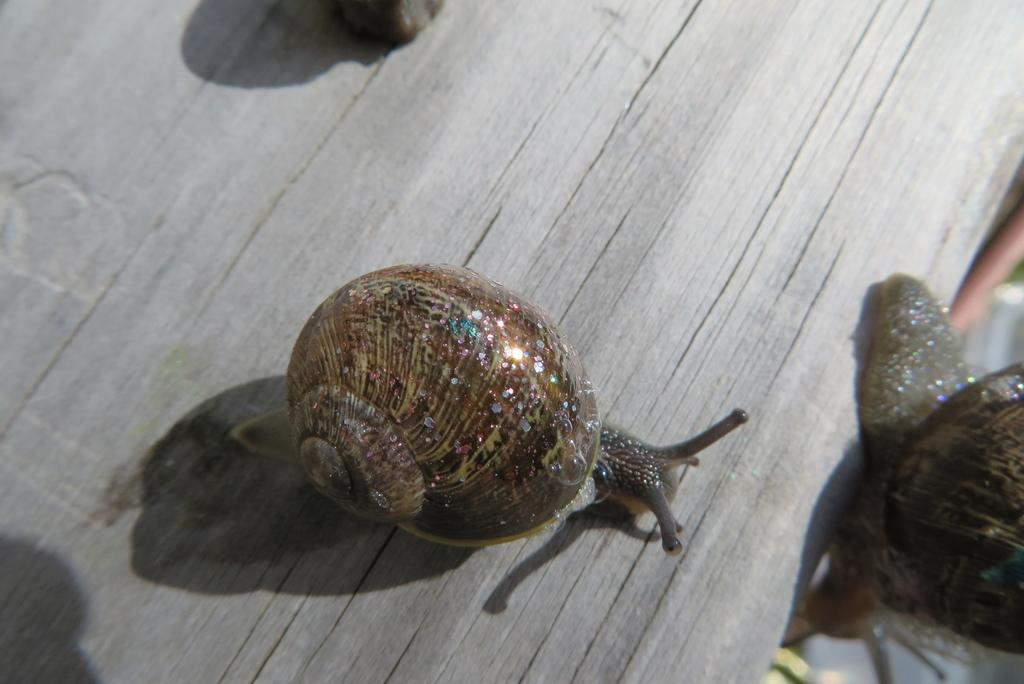What type of animal is in the image? There is a snail in the image. What is the snail resting on? The snail is on a wooden object. What arithmetic problem is the snail solving in the image? There is no arithmetic problem present in the image, as it features a snail on a wooden object. How does the needle interact with the snail in the image? There is no needle present in the image, so it cannot interact with the snail. 